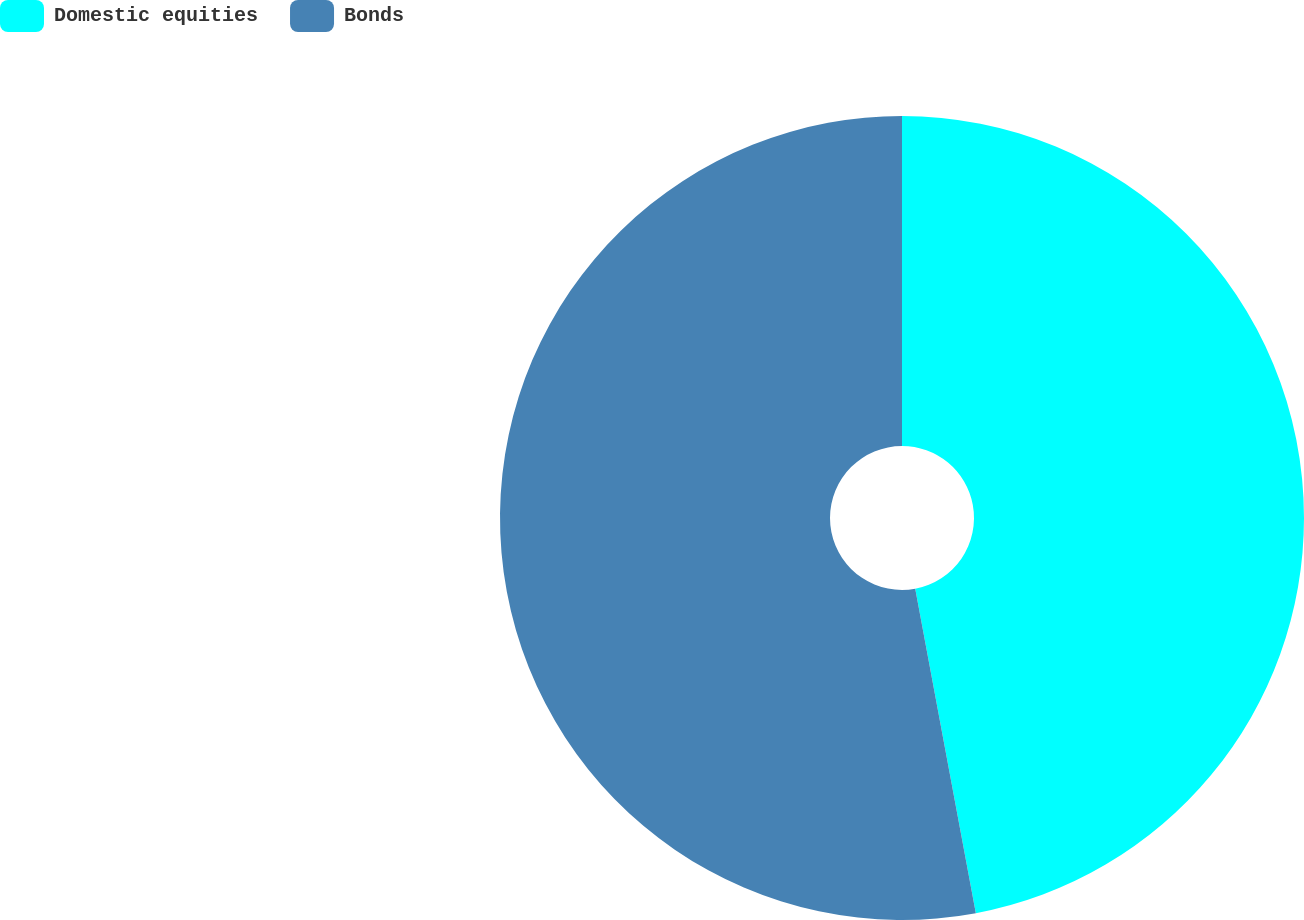Convert chart. <chart><loc_0><loc_0><loc_500><loc_500><pie_chart><fcel>Domestic equities<fcel>Bonds<nl><fcel>47.06%<fcel>52.94%<nl></chart> 